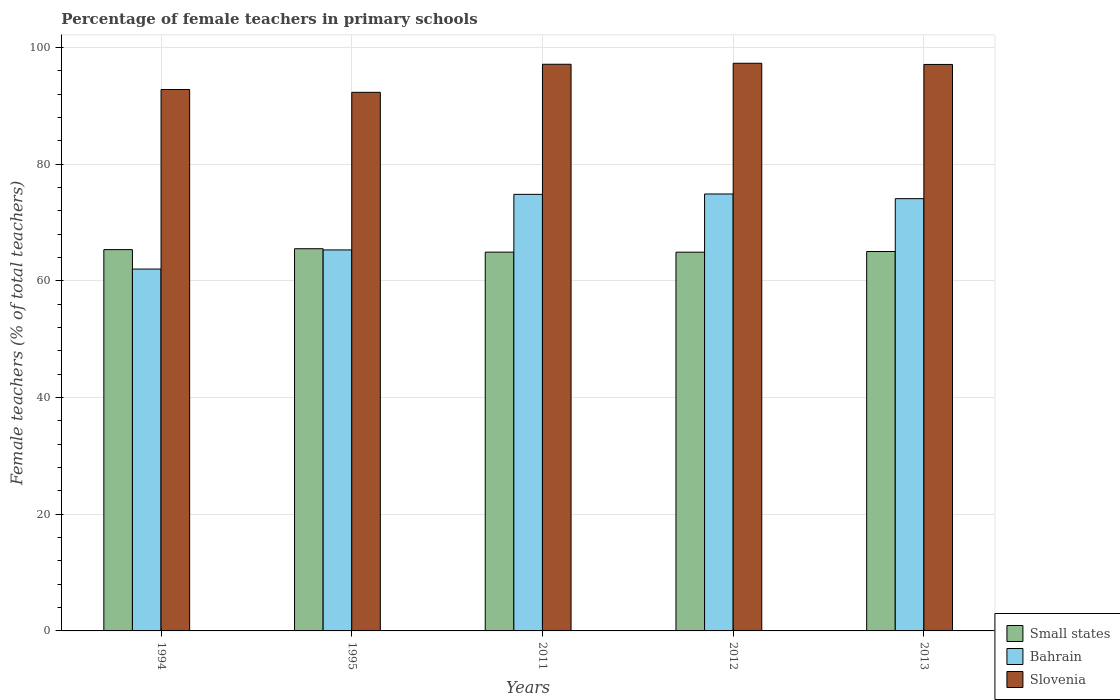How many groups of bars are there?
Offer a very short reply. 5. Are the number of bars per tick equal to the number of legend labels?
Your answer should be compact. Yes. Are the number of bars on each tick of the X-axis equal?
Offer a terse response. Yes. How many bars are there on the 5th tick from the left?
Provide a short and direct response. 3. In how many cases, is the number of bars for a given year not equal to the number of legend labels?
Give a very brief answer. 0. What is the percentage of female teachers in Bahrain in 2013?
Ensure brevity in your answer.  74.09. Across all years, what is the maximum percentage of female teachers in Small states?
Ensure brevity in your answer.  65.51. Across all years, what is the minimum percentage of female teachers in Bahrain?
Offer a terse response. 62.02. In which year was the percentage of female teachers in Bahrain minimum?
Offer a terse response. 1994. What is the total percentage of female teachers in Bahrain in the graph?
Provide a short and direct response. 351.13. What is the difference between the percentage of female teachers in Small states in 1994 and that in 2012?
Keep it short and to the point. 0.44. What is the difference between the percentage of female teachers in Small states in 2012 and the percentage of female teachers in Slovenia in 1994?
Make the answer very short. -27.88. What is the average percentage of female teachers in Small states per year?
Provide a short and direct response. 65.15. In the year 1994, what is the difference between the percentage of female teachers in Slovenia and percentage of female teachers in Small states?
Offer a terse response. 27.45. In how many years, is the percentage of female teachers in Small states greater than 24 %?
Offer a terse response. 5. What is the ratio of the percentage of female teachers in Bahrain in 1995 to that in 2013?
Provide a short and direct response. 0.88. Is the percentage of female teachers in Small states in 1995 less than that in 2012?
Your answer should be very brief. No. What is the difference between the highest and the second highest percentage of female teachers in Slovenia?
Provide a succinct answer. 0.17. What is the difference between the highest and the lowest percentage of female teachers in Slovenia?
Your answer should be compact. 4.98. In how many years, is the percentage of female teachers in Small states greater than the average percentage of female teachers in Small states taken over all years?
Offer a terse response. 2. What does the 2nd bar from the left in 2011 represents?
Give a very brief answer. Bahrain. What does the 2nd bar from the right in 2013 represents?
Your answer should be very brief. Bahrain. How many bars are there?
Provide a succinct answer. 15. Are all the bars in the graph horizontal?
Your response must be concise. No. What is the difference between two consecutive major ticks on the Y-axis?
Provide a succinct answer. 20. Are the values on the major ticks of Y-axis written in scientific E-notation?
Your answer should be very brief. No. Does the graph contain any zero values?
Ensure brevity in your answer.  No. Does the graph contain grids?
Offer a terse response. Yes. How are the legend labels stacked?
Keep it short and to the point. Vertical. What is the title of the graph?
Your response must be concise. Percentage of female teachers in primary schools. What is the label or title of the Y-axis?
Provide a short and direct response. Female teachers (% of total teachers). What is the Female teachers (% of total teachers) of Small states in 1994?
Your response must be concise. 65.35. What is the Female teachers (% of total teachers) in Bahrain in 1994?
Ensure brevity in your answer.  62.02. What is the Female teachers (% of total teachers) of Slovenia in 1994?
Your response must be concise. 92.8. What is the Female teachers (% of total teachers) of Small states in 1995?
Your response must be concise. 65.51. What is the Female teachers (% of total teachers) of Bahrain in 1995?
Give a very brief answer. 65.3. What is the Female teachers (% of total teachers) in Slovenia in 1995?
Your answer should be very brief. 92.32. What is the Female teachers (% of total teachers) in Small states in 2011?
Your answer should be compact. 64.93. What is the Female teachers (% of total teachers) in Bahrain in 2011?
Ensure brevity in your answer.  74.83. What is the Female teachers (% of total teachers) of Slovenia in 2011?
Give a very brief answer. 97.13. What is the Female teachers (% of total teachers) of Small states in 2012?
Your response must be concise. 64.92. What is the Female teachers (% of total teachers) of Bahrain in 2012?
Provide a succinct answer. 74.89. What is the Female teachers (% of total teachers) in Slovenia in 2012?
Provide a short and direct response. 97.3. What is the Female teachers (% of total teachers) of Small states in 2013?
Your answer should be compact. 65.03. What is the Female teachers (% of total teachers) of Bahrain in 2013?
Ensure brevity in your answer.  74.09. What is the Female teachers (% of total teachers) of Slovenia in 2013?
Your response must be concise. 97.09. Across all years, what is the maximum Female teachers (% of total teachers) of Small states?
Your answer should be very brief. 65.51. Across all years, what is the maximum Female teachers (% of total teachers) in Bahrain?
Ensure brevity in your answer.  74.89. Across all years, what is the maximum Female teachers (% of total teachers) in Slovenia?
Offer a terse response. 97.3. Across all years, what is the minimum Female teachers (% of total teachers) of Small states?
Offer a terse response. 64.92. Across all years, what is the minimum Female teachers (% of total teachers) of Bahrain?
Your answer should be compact. 62.02. Across all years, what is the minimum Female teachers (% of total teachers) in Slovenia?
Your answer should be very brief. 92.32. What is the total Female teachers (% of total teachers) of Small states in the graph?
Your response must be concise. 325.73. What is the total Female teachers (% of total teachers) in Bahrain in the graph?
Provide a succinct answer. 351.13. What is the total Female teachers (% of total teachers) in Slovenia in the graph?
Your answer should be compact. 476.63. What is the difference between the Female teachers (% of total teachers) of Small states in 1994 and that in 1995?
Provide a short and direct response. -0.15. What is the difference between the Female teachers (% of total teachers) of Bahrain in 1994 and that in 1995?
Provide a short and direct response. -3.28. What is the difference between the Female teachers (% of total teachers) of Slovenia in 1994 and that in 1995?
Provide a short and direct response. 0.48. What is the difference between the Female teachers (% of total teachers) of Small states in 1994 and that in 2011?
Provide a succinct answer. 0.43. What is the difference between the Female teachers (% of total teachers) of Bahrain in 1994 and that in 2011?
Give a very brief answer. -12.81. What is the difference between the Female teachers (% of total teachers) of Slovenia in 1994 and that in 2011?
Provide a short and direct response. -4.33. What is the difference between the Female teachers (% of total teachers) of Small states in 1994 and that in 2012?
Provide a short and direct response. 0.44. What is the difference between the Female teachers (% of total teachers) in Bahrain in 1994 and that in 2012?
Your answer should be very brief. -12.87. What is the difference between the Female teachers (% of total teachers) in Slovenia in 1994 and that in 2012?
Ensure brevity in your answer.  -4.5. What is the difference between the Female teachers (% of total teachers) of Small states in 1994 and that in 2013?
Offer a very short reply. 0.32. What is the difference between the Female teachers (% of total teachers) in Bahrain in 1994 and that in 2013?
Offer a terse response. -12.07. What is the difference between the Female teachers (% of total teachers) of Slovenia in 1994 and that in 2013?
Make the answer very short. -4.29. What is the difference between the Female teachers (% of total teachers) of Small states in 1995 and that in 2011?
Keep it short and to the point. 0.58. What is the difference between the Female teachers (% of total teachers) of Bahrain in 1995 and that in 2011?
Offer a very short reply. -9.53. What is the difference between the Female teachers (% of total teachers) in Slovenia in 1995 and that in 2011?
Your response must be concise. -4.81. What is the difference between the Female teachers (% of total teachers) of Small states in 1995 and that in 2012?
Your answer should be very brief. 0.59. What is the difference between the Female teachers (% of total teachers) in Bahrain in 1995 and that in 2012?
Keep it short and to the point. -9.59. What is the difference between the Female teachers (% of total teachers) of Slovenia in 1995 and that in 2012?
Your answer should be compact. -4.98. What is the difference between the Female teachers (% of total teachers) in Small states in 1995 and that in 2013?
Keep it short and to the point. 0.48. What is the difference between the Female teachers (% of total teachers) in Bahrain in 1995 and that in 2013?
Offer a terse response. -8.79. What is the difference between the Female teachers (% of total teachers) of Slovenia in 1995 and that in 2013?
Provide a short and direct response. -4.78. What is the difference between the Female teachers (% of total teachers) in Bahrain in 2011 and that in 2012?
Keep it short and to the point. -0.06. What is the difference between the Female teachers (% of total teachers) in Slovenia in 2011 and that in 2012?
Provide a short and direct response. -0.17. What is the difference between the Female teachers (% of total teachers) of Small states in 2011 and that in 2013?
Give a very brief answer. -0.11. What is the difference between the Female teachers (% of total teachers) of Bahrain in 2011 and that in 2013?
Provide a short and direct response. 0.74. What is the difference between the Female teachers (% of total teachers) of Slovenia in 2011 and that in 2013?
Your answer should be compact. 0.03. What is the difference between the Female teachers (% of total teachers) of Small states in 2012 and that in 2013?
Keep it short and to the point. -0.12. What is the difference between the Female teachers (% of total teachers) of Bahrain in 2012 and that in 2013?
Make the answer very short. 0.8. What is the difference between the Female teachers (% of total teachers) of Slovenia in 2012 and that in 2013?
Provide a succinct answer. 0.2. What is the difference between the Female teachers (% of total teachers) in Small states in 1994 and the Female teachers (% of total teachers) in Bahrain in 1995?
Provide a short and direct response. 0.05. What is the difference between the Female teachers (% of total teachers) in Small states in 1994 and the Female teachers (% of total teachers) in Slovenia in 1995?
Your response must be concise. -26.96. What is the difference between the Female teachers (% of total teachers) in Bahrain in 1994 and the Female teachers (% of total teachers) in Slovenia in 1995?
Your answer should be compact. -30.3. What is the difference between the Female teachers (% of total teachers) of Small states in 1994 and the Female teachers (% of total teachers) of Bahrain in 2011?
Your answer should be compact. -9.47. What is the difference between the Female teachers (% of total teachers) of Small states in 1994 and the Female teachers (% of total teachers) of Slovenia in 2011?
Keep it short and to the point. -31.77. What is the difference between the Female teachers (% of total teachers) in Bahrain in 1994 and the Female teachers (% of total teachers) in Slovenia in 2011?
Provide a succinct answer. -35.11. What is the difference between the Female teachers (% of total teachers) of Small states in 1994 and the Female teachers (% of total teachers) of Bahrain in 2012?
Your response must be concise. -9.54. What is the difference between the Female teachers (% of total teachers) in Small states in 1994 and the Female teachers (% of total teachers) in Slovenia in 2012?
Your answer should be very brief. -31.94. What is the difference between the Female teachers (% of total teachers) in Bahrain in 1994 and the Female teachers (% of total teachers) in Slovenia in 2012?
Make the answer very short. -35.28. What is the difference between the Female teachers (% of total teachers) in Small states in 1994 and the Female teachers (% of total teachers) in Bahrain in 2013?
Provide a succinct answer. -8.73. What is the difference between the Female teachers (% of total teachers) in Small states in 1994 and the Female teachers (% of total teachers) in Slovenia in 2013?
Provide a short and direct response. -31.74. What is the difference between the Female teachers (% of total teachers) in Bahrain in 1994 and the Female teachers (% of total teachers) in Slovenia in 2013?
Keep it short and to the point. -35.07. What is the difference between the Female teachers (% of total teachers) of Small states in 1995 and the Female teachers (% of total teachers) of Bahrain in 2011?
Your response must be concise. -9.32. What is the difference between the Female teachers (% of total teachers) of Small states in 1995 and the Female teachers (% of total teachers) of Slovenia in 2011?
Keep it short and to the point. -31.62. What is the difference between the Female teachers (% of total teachers) of Bahrain in 1995 and the Female teachers (% of total teachers) of Slovenia in 2011?
Your answer should be very brief. -31.83. What is the difference between the Female teachers (% of total teachers) in Small states in 1995 and the Female teachers (% of total teachers) in Bahrain in 2012?
Offer a very short reply. -9.38. What is the difference between the Female teachers (% of total teachers) of Small states in 1995 and the Female teachers (% of total teachers) of Slovenia in 2012?
Offer a terse response. -31.79. What is the difference between the Female teachers (% of total teachers) of Bahrain in 1995 and the Female teachers (% of total teachers) of Slovenia in 2012?
Keep it short and to the point. -32. What is the difference between the Female teachers (% of total teachers) of Small states in 1995 and the Female teachers (% of total teachers) of Bahrain in 2013?
Ensure brevity in your answer.  -8.58. What is the difference between the Female teachers (% of total teachers) of Small states in 1995 and the Female teachers (% of total teachers) of Slovenia in 2013?
Offer a terse response. -31.59. What is the difference between the Female teachers (% of total teachers) in Bahrain in 1995 and the Female teachers (% of total teachers) in Slovenia in 2013?
Provide a short and direct response. -31.79. What is the difference between the Female teachers (% of total teachers) in Small states in 2011 and the Female teachers (% of total teachers) in Bahrain in 2012?
Offer a very short reply. -9.97. What is the difference between the Female teachers (% of total teachers) in Small states in 2011 and the Female teachers (% of total teachers) in Slovenia in 2012?
Give a very brief answer. -32.37. What is the difference between the Female teachers (% of total teachers) in Bahrain in 2011 and the Female teachers (% of total teachers) in Slovenia in 2012?
Make the answer very short. -22.47. What is the difference between the Female teachers (% of total teachers) of Small states in 2011 and the Female teachers (% of total teachers) of Bahrain in 2013?
Ensure brevity in your answer.  -9.16. What is the difference between the Female teachers (% of total teachers) in Small states in 2011 and the Female teachers (% of total teachers) in Slovenia in 2013?
Offer a very short reply. -32.17. What is the difference between the Female teachers (% of total teachers) of Bahrain in 2011 and the Female teachers (% of total teachers) of Slovenia in 2013?
Keep it short and to the point. -22.27. What is the difference between the Female teachers (% of total teachers) of Small states in 2012 and the Female teachers (% of total teachers) of Bahrain in 2013?
Offer a terse response. -9.17. What is the difference between the Female teachers (% of total teachers) of Small states in 2012 and the Female teachers (% of total teachers) of Slovenia in 2013?
Your answer should be very brief. -32.18. What is the difference between the Female teachers (% of total teachers) in Bahrain in 2012 and the Female teachers (% of total teachers) in Slovenia in 2013?
Your answer should be very brief. -22.2. What is the average Female teachers (% of total teachers) in Small states per year?
Your answer should be very brief. 65.15. What is the average Female teachers (% of total teachers) of Bahrain per year?
Your answer should be compact. 70.23. What is the average Female teachers (% of total teachers) of Slovenia per year?
Provide a short and direct response. 95.33. In the year 1994, what is the difference between the Female teachers (% of total teachers) in Small states and Female teachers (% of total teachers) in Bahrain?
Make the answer very short. 3.33. In the year 1994, what is the difference between the Female teachers (% of total teachers) of Small states and Female teachers (% of total teachers) of Slovenia?
Provide a short and direct response. -27.45. In the year 1994, what is the difference between the Female teachers (% of total teachers) in Bahrain and Female teachers (% of total teachers) in Slovenia?
Your response must be concise. -30.78. In the year 1995, what is the difference between the Female teachers (% of total teachers) in Small states and Female teachers (% of total teachers) in Bahrain?
Provide a succinct answer. 0.21. In the year 1995, what is the difference between the Female teachers (% of total teachers) of Small states and Female teachers (% of total teachers) of Slovenia?
Offer a very short reply. -26.81. In the year 1995, what is the difference between the Female teachers (% of total teachers) of Bahrain and Female teachers (% of total teachers) of Slovenia?
Provide a succinct answer. -27.02. In the year 2011, what is the difference between the Female teachers (% of total teachers) of Small states and Female teachers (% of total teachers) of Bahrain?
Provide a succinct answer. -9.9. In the year 2011, what is the difference between the Female teachers (% of total teachers) in Small states and Female teachers (% of total teachers) in Slovenia?
Your answer should be compact. -32.2. In the year 2011, what is the difference between the Female teachers (% of total teachers) in Bahrain and Female teachers (% of total teachers) in Slovenia?
Offer a terse response. -22.3. In the year 2012, what is the difference between the Female teachers (% of total teachers) of Small states and Female teachers (% of total teachers) of Bahrain?
Ensure brevity in your answer.  -9.98. In the year 2012, what is the difference between the Female teachers (% of total teachers) of Small states and Female teachers (% of total teachers) of Slovenia?
Your answer should be very brief. -32.38. In the year 2012, what is the difference between the Female teachers (% of total teachers) in Bahrain and Female teachers (% of total teachers) in Slovenia?
Provide a short and direct response. -22.4. In the year 2013, what is the difference between the Female teachers (% of total teachers) in Small states and Female teachers (% of total teachers) in Bahrain?
Offer a very short reply. -9.06. In the year 2013, what is the difference between the Female teachers (% of total teachers) of Small states and Female teachers (% of total teachers) of Slovenia?
Provide a succinct answer. -32.06. In the year 2013, what is the difference between the Female teachers (% of total teachers) in Bahrain and Female teachers (% of total teachers) in Slovenia?
Make the answer very short. -23.01. What is the ratio of the Female teachers (% of total teachers) in Small states in 1994 to that in 1995?
Make the answer very short. 1. What is the ratio of the Female teachers (% of total teachers) of Bahrain in 1994 to that in 1995?
Your response must be concise. 0.95. What is the ratio of the Female teachers (% of total teachers) of Small states in 1994 to that in 2011?
Keep it short and to the point. 1.01. What is the ratio of the Female teachers (% of total teachers) in Bahrain in 1994 to that in 2011?
Your answer should be very brief. 0.83. What is the ratio of the Female teachers (% of total teachers) in Slovenia in 1994 to that in 2011?
Provide a succinct answer. 0.96. What is the ratio of the Female teachers (% of total teachers) in Small states in 1994 to that in 2012?
Your answer should be compact. 1.01. What is the ratio of the Female teachers (% of total teachers) in Bahrain in 1994 to that in 2012?
Your answer should be compact. 0.83. What is the ratio of the Female teachers (% of total teachers) of Slovenia in 1994 to that in 2012?
Provide a short and direct response. 0.95. What is the ratio of the Female teachers (% of total teachers) in Bahrain in 1994 to that in 2013?
Offer a terse response. 0.84. What is the ratio of the Female teachers (% of total teachers) in Slovenia in 1994 to that in 2013?
Offer a terse response. 0.96. What is the ratio of the Female teachers (% of total teachers) of Bahrain in 1995 to that in 2011?
Offer a very short reply. 0.87. What is the ratio of the Female teachers (% of total teachers) of Slovenia in 1995 to that in 2011?
Provide a short and direct response. 0.95. What is the ratio of the Female teachers (% of total teachers) in Small states in 1995 to that in 2012?
Your answer should be very brief. 1.01. What is the ratio of the Female teachers (% of total teachers) of Bahrain in 1995 to that in 2012?
Offer a terse response. 0.87. What is the ratio of the Female teachers (% of total teachers) in Slovenia in 1995 to that in 2012?
Your response must be concise. 0.95. What is the ratio of the Female teachers (% of total teachers) of Small states in 1995 to that in 2013?
Provide a short and direct response. 1.01. What is the ratio of the Female teachers (% of total teachers) in Bahrain in 1995 to that in 2013?
Offer a very short reply. 0.88. What is the ratio of the Female teachers (% of total teachers) in Slovenia in 1995 to that in 2013?
Keep it short and to the point. 0.95. What is the ratio of the Female teachers (% of total teachers) of Small states in 2011 to that in 2013?
Make the answer very short. 1. What is the ratio of the Female teachers (% of total teachers) of Slovenia in 2011 to that in 2013?
Your answer should be compact. 1. What is the ratio of the Female teachers (% of total teachers) of Bahrain in 2012 to that in 2013?
Ensure brevity in your answer.  1.01. What is the ratio of the Female teachers (% of total teachers) of Slovenia in 2012 to that in 2013?
Ensure brevity in your answer.  1. What is the difference between the highest and the second highest Female teachers (% of total teachers) of Small states?
Ensure brevity in your answer.  0.15. What is the difference between the highest and the second highest Female teachers (% of total teachers) of Bahrain?
Make the answer very short. 0.06. What is the difference between the highest and the second highest Female teachers (% of total teachers) in Slovenia?
Offer a very short reply. 0.17. What is the difference between the highest and the lowest Female teachers (% of total teachers) in Small states?
Provide a short and direct response. 0.59. What is the difference between the highest and the lowest Female teachers (% of total teachers) in Bahrain?
Provide a succinct answer. 12.87. What is the difference between the highest and the lowest Female teachers (% of total teachers) of Slovenia?
Give a very brief answer. 4.98. 